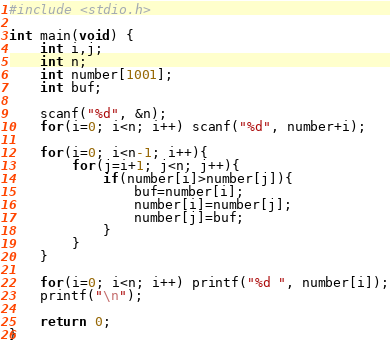<code> <loc_0><loc_0><loc_500><loc_500><_C_>#include <stdio.h>
 
int main(void) {
    int i,j;
    int n;
    int number[1001];
    int buf;
    
    scanf("%d", &n);
    for(i=0; i<n; i++) scanf("%d", number+i);
    
    for(i=0; i<n-1; i++){
        for(j=i+1; j<n; j++){
            if(number[i]>number[j]){
                buf=number[i];
                number[i]=number[j];
                number[j]=buf;
            }            
        }
    }
    
    for(i=0; i<n; i++) printf("%d ", number[i]);
    printf("\n");
    
    return 0;
}</code> 